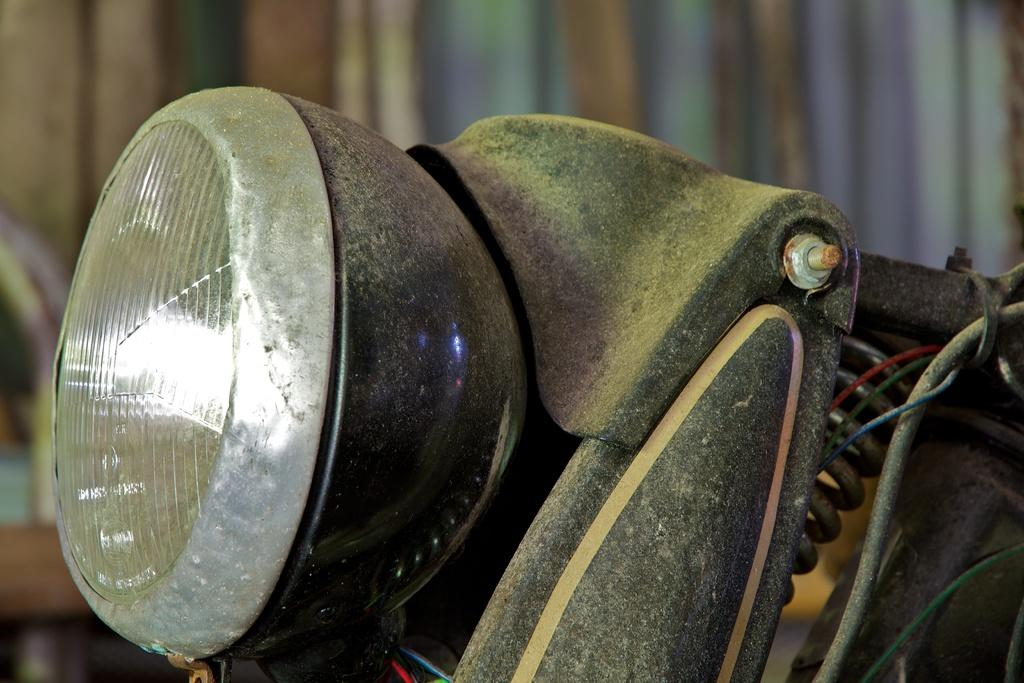What is the main subject of the image? There is a vehicle in the image. What color is the vehicle? The vehicle is black in color. Can you describe any other objects or features in the image? There is a light in the image. What can be seen in the background of the image? The background of the image is multicolored. What type of copper material is used to construct the hill in the image? There is no hill or copper material present in the image. 